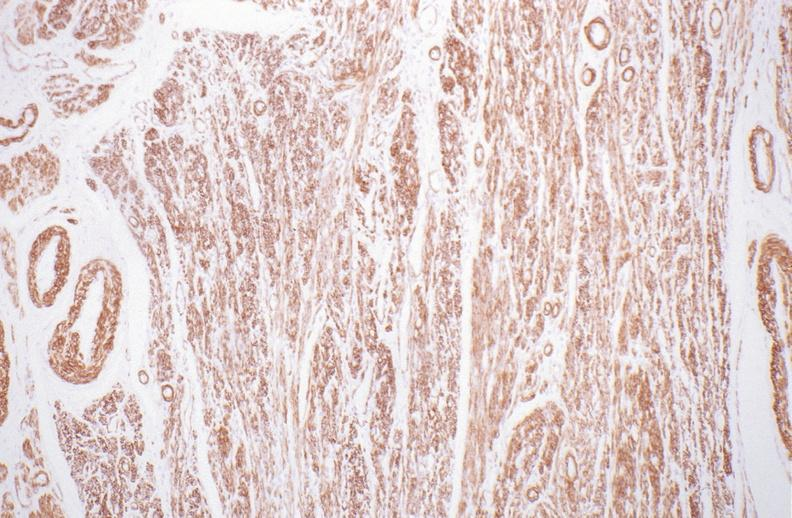what is present?
Answer the question using a single word or phrase. Female reproductive 